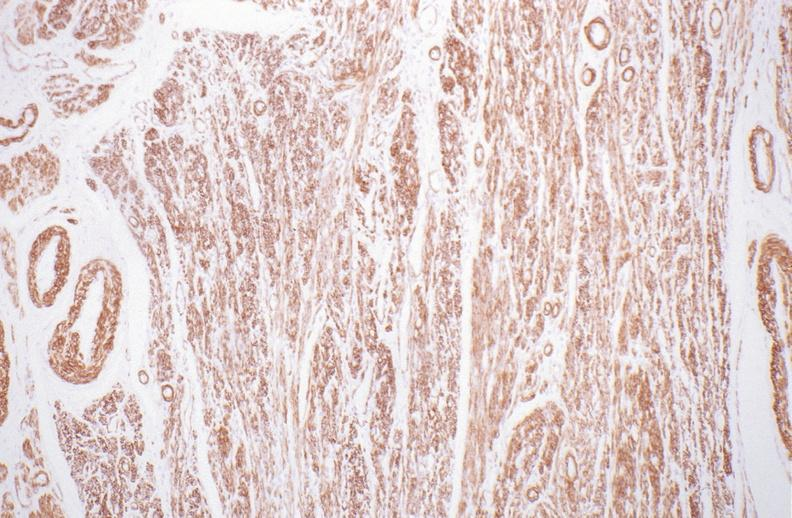what is present?
Answer the question using a single word or phrase. Female reproductive 